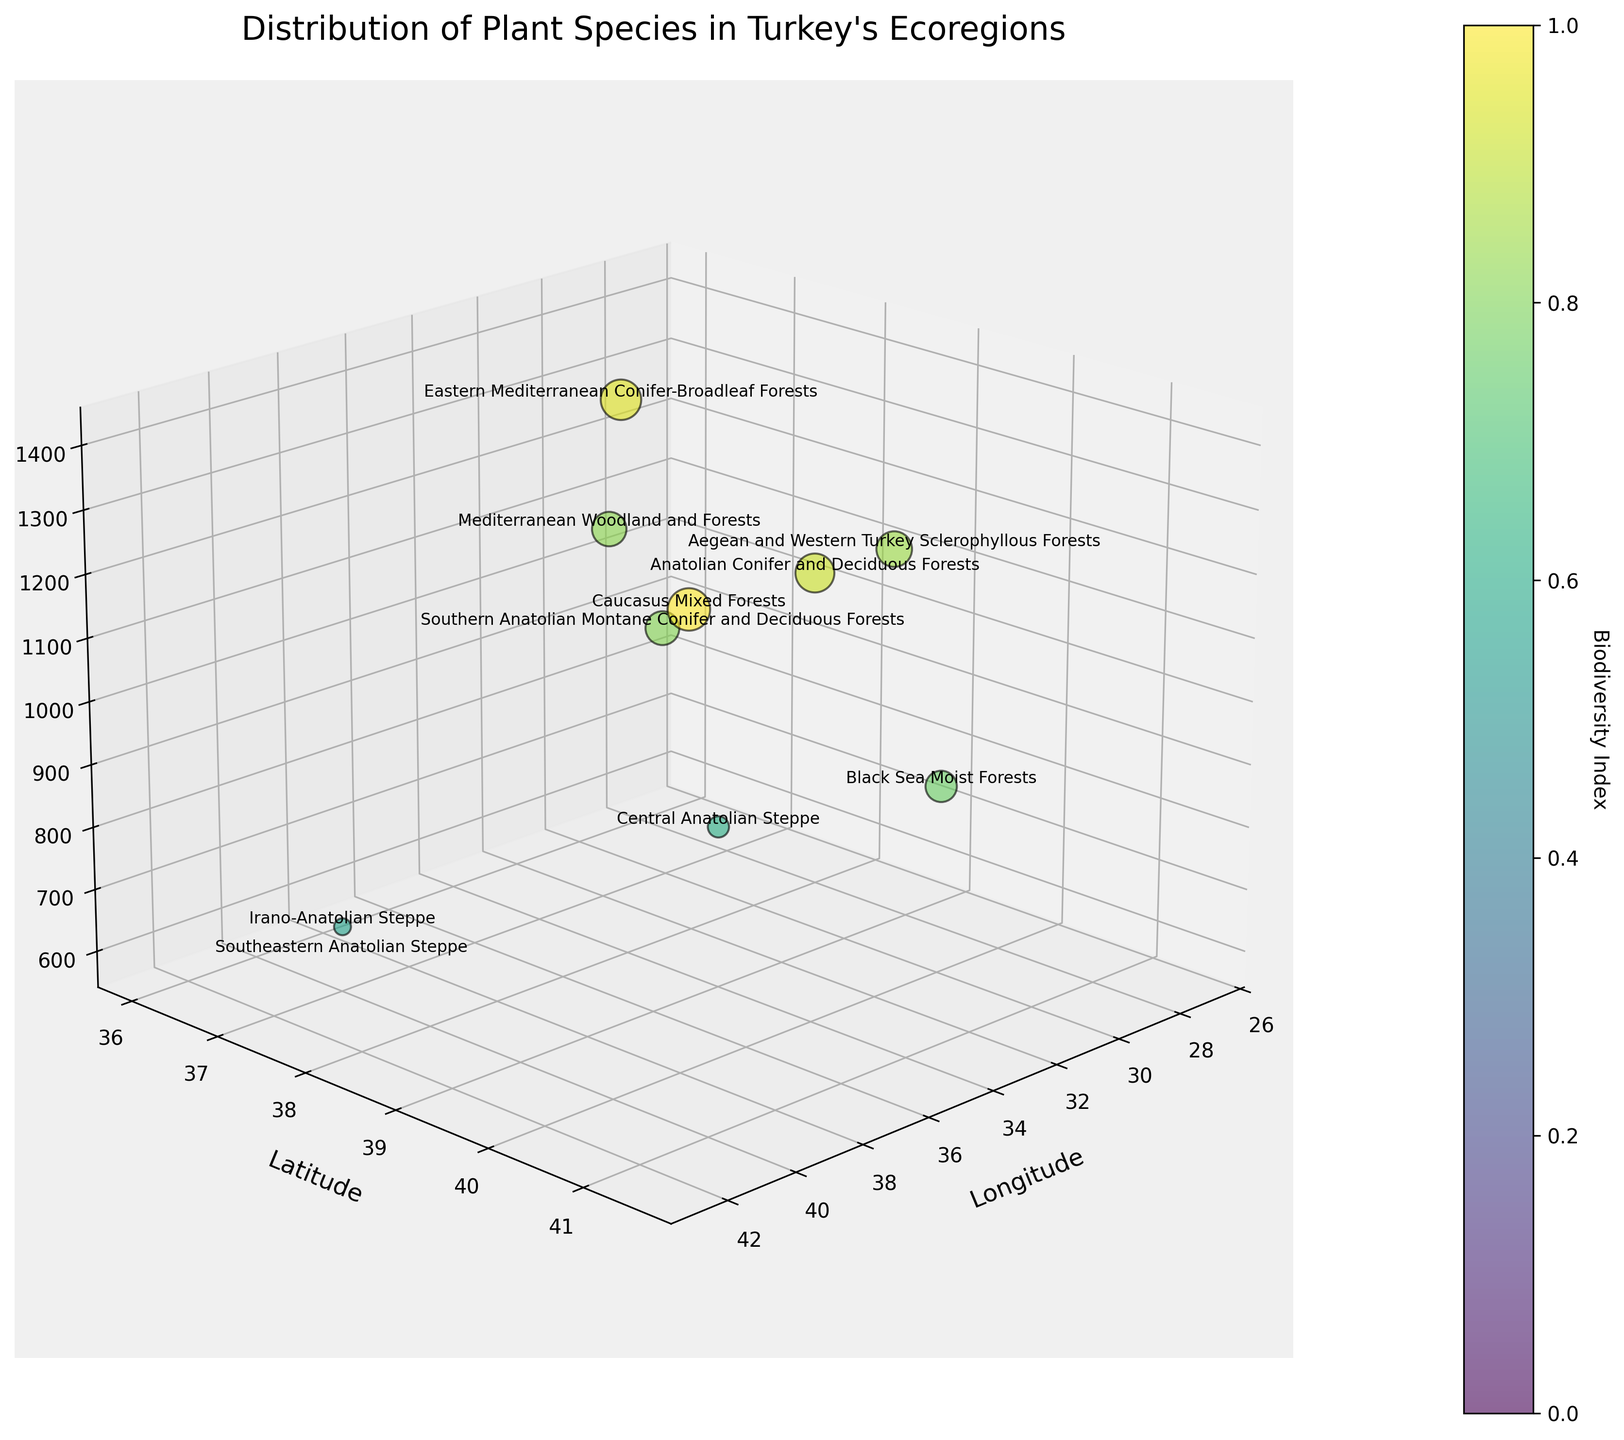What is the title of the figure? The title of the figure is displayed prominently at the top of the chart.
Answer: Distribution of Plant Species in Turkey's Ecoregions Which axis represents Latitude? The figure labels each axis, and the Y-axis is labeled 'Latitude' on the chart.
Answer: Y-axis How many ecoregions are displayed in the figure? Each bubble corresponds to one ecoregion, and by counting the bubbles, you can see there are ten ecoregions represented.
Answer: 10 Which ecoregion has the highest biodiversity index? The color map indicates the biodiversity index, with the most vibrant color corresponding to the highest index. By identifying the most vibrant color, the ecoregion corresponding to this color is the 'Caucasus Mixed Forests' located at latitude 41.5, longitude 42.0.
Answer: Caucasus Mixed Forests What are the range values for species count shown in the figure? The Z-axis represents the number of species, and from the highest and lowest points on the Z-axis, we can see that the count ranges from 600 to 1400 species.
Answer: 600 to 1400 species Which ecoregion is located furthest east? By examining the values along the Longitude (X-axis), the ecoregion furthest east is the one with the highest longitude value of 42.5, which is the 'Irano-Anatolian Steppe.'
Answer: Irano-Anatolian Steppe Which two ecoregions have the closest species count? By comparing the bubbles' z-axis positions, 'Southern Anatolian Montane Conifer and Deciduous Forests' (1000 species) and 'Mediterranean Woodland and Forests' (1050 species) have the closest species counts.
Answer: Southern Anatolian Montane Conifer and Deciduous Forests and Mediterranean Woodland and Forests Which ecoregion is represented by the smallest bubble size? The size of the bubble represents biodiversity, and the smallest bubble size correlates to the 'Southeastern Anatolian Steppe,' which has the lowest biodiversity index of 4.1.
Answer: Southeastern Anatolian Steppe What is the combined biodiversity index of the 'Anatolian Conifer and Deciduous Forests' and 'Mediterranean Woodland and Forests'? Summing up the biodiversity indices shown in the figure for these two regions, 7.8 and 7.0 respectively, gives a total of 14.8.
Answer: 14.8 Between the 'Black Sea Moist Forests' and 'Central Anatolian Steppe,' which has a higher species count, and by how much? The species count for 'Black Sea Moist Forests' is 950 and for 'Central Anatolian Steppe' is 800. The difference is 950 - 800, so 'Black Sea Moist Forests' has 150 more species.
Answer: Black Sea Moist Forests by 150 species 